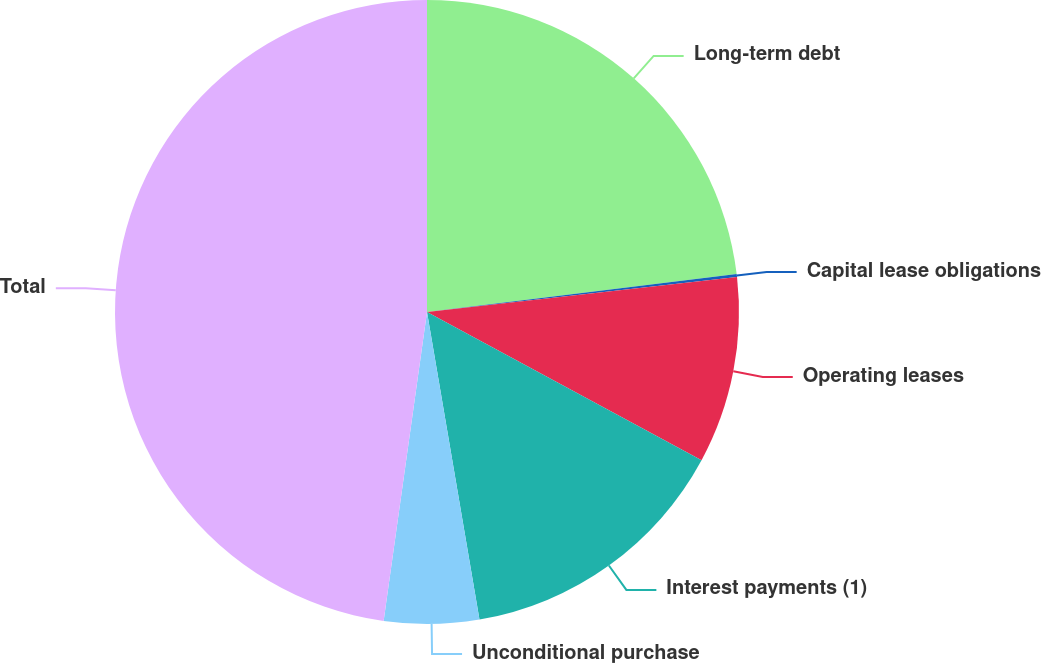Convert chart to OTSL. <chart><loc_0><loc_0><loc_500><loc_500><pie_chart><fcel>Long-term debt<fcel>Capital lease obligations<fcel>Operating leases<fcel>Interest payments (1)<fcel>Unconditional purchase<fcel>Total<nl><fcel>23.06%<fcel>0.15%<fcel>9.67%<fcel>14.43%<fcel>4.91%<fcel>47.78%<nl></chart> 